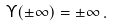Convert formula to latex. <formula><loc_0><loc_0><loc_500><loc_500>\Upsilon ( \pm \infty ) = \pm \infty \, .</formula> 